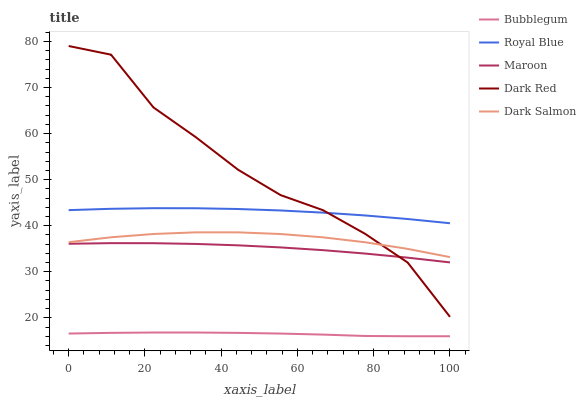Does Bubblegum have the minimum area under the curve?
Answer yes or no. Yes. Does Dark Red have the maximum area under the curve?
Answer yes or no. Yes. Does Dark Salmon have the minimum area under the curve?
Answer yes or no. No. Does Dark Salmon have the maximum area under the curve?
Answer yes or no. No. Is Bubblegum the smoothest?
Answer yes or no. Yes. Is Dark Red the roughest?
Answer yes or no. Yes. Is Dark Salmon the smoothest?
Answer yes or no. No. Is Dark Salmon the roughest?
Answer yes or no. No. Does Bubblegum have the lowest value?
Answer yes or no. Yes. Does Dark Salmon have the lowest value?
Answer yes or no. No. Does Dark Red have the highest value?
Answer yes or no. Yes. Does Dark Salmon have the highest value?
Answer yes or no. No. Is Maroon less than Royal Blue?
Answer yes or no. Yes. Is Dark Salmon greater than Maroon?
Answer yes or no. Yes. Does Dark Red intersect Maroon?
Answer yes or no. Yes. Is Dark Red less than Maroon?
Answer yes or no. No. Is Dark Red greater than Maroon?
Answer yes or no. No. Does Maroon intersect Royal Blue?
Answer yes or no. No. 